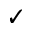Convert formula to latex. <formula><loc_0><loc_0><loc_500><loc_500>\check { m } a r k</formula> 